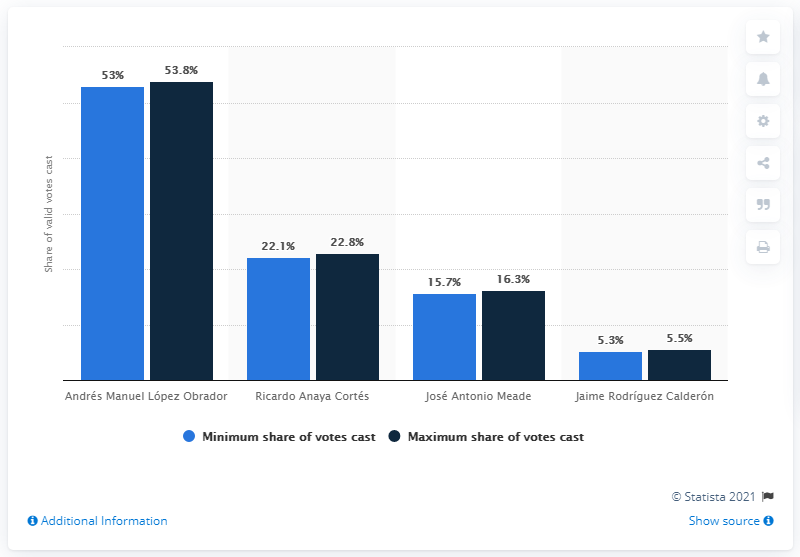Point out several critical features in this image. Andrés Manuel López Obrador, also known by his initials AMLO, is a public figure. 